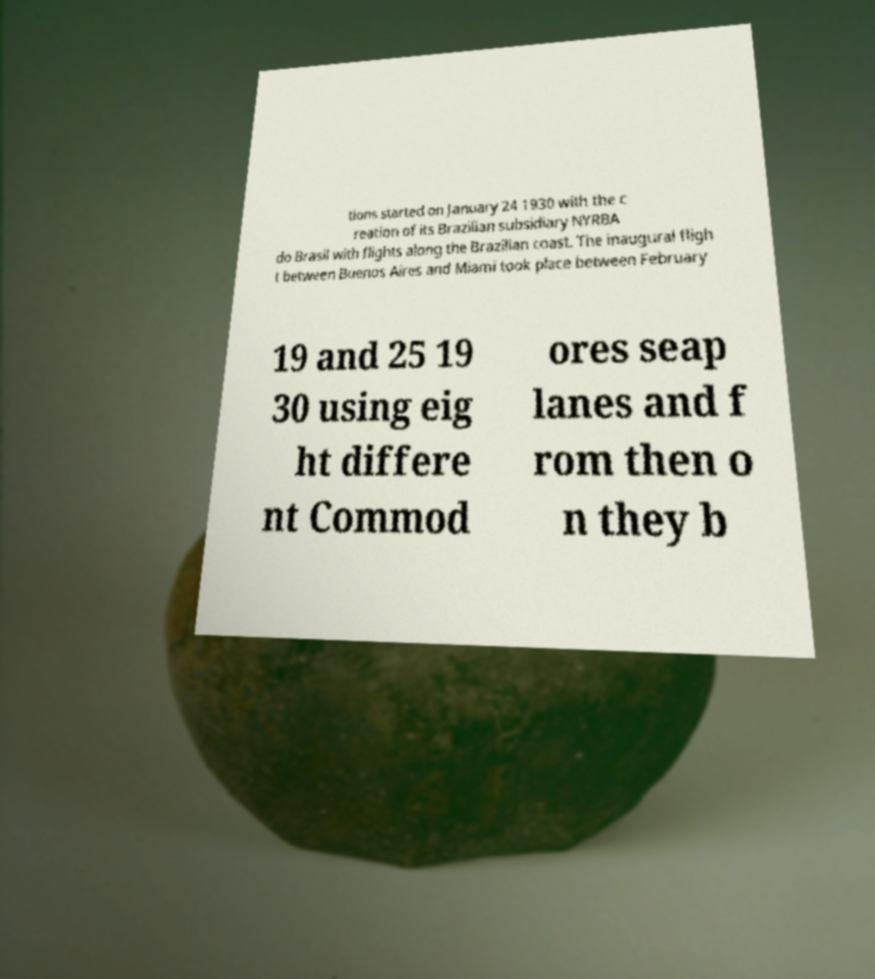Could you extract and type out the text from this image? tions started on January 24 1930 with the c reation of its Brazilian subsidiary NYRBA do Brasil with flights along the Brazilian coast. The inaugural fligh t between Buenos Aires and Miami took place between February 19 and 25 19 30 using eig ht differe nt Commod ores seap lanes and f rom then o n they b 